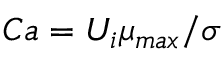Convert formula to latex. <formula><loc_0><loc_0><loc_500><loc_500>C a = { U _ { i } \mu _ { \max } } / { \sigma }</formula> 